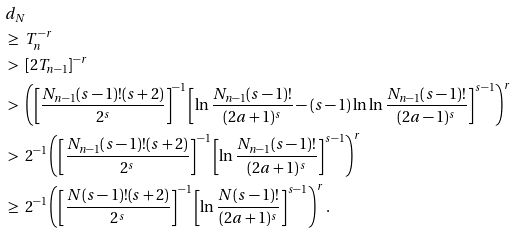<formula> <loc_0><loc_0><loc_500><loc_500>& d _ { N } \\ \ & \geq \ T _ { n } ^ { - r } \\ \ & > \ \left [ 2 T _ { n - 1 } \right ] ^ { - r } \\ \ & > \ \left ( \left [ \frac { N _ { n - 1 } ( s - 1 ) ! ( s + 2 ) } { 2 ^ { s } } \right ] ^ { - 1 } \left [ \ln \frac { N _ { n - 1 } ( s - 1 ) ! } { ( 2 a + 1 ) ^ { s } } - ( s - 1 ) \ln \ln \frac { N _ { n - 1 } ( s - 1 ) ! } { ( 2 a - 1 ) ^ { s } } \right ] ^ { s - 1 } \right ) ^ { r } \\ \ & > \ 2 ^ { - 1 } \left ( \left [ \frac { N _ { n - 1 } ( s - 1 ) ! ( s + 2 ) } { 2 ^ { s } } \right ] ^ { - 1 } \left [ \ln \frac { N _ { n - 1 } ( s - 1 ) ! } { ( 2 a + 1 ) ^ { s } } \right ] ^ { s - 1 } \right ) ^ { r } \\ \ & \geq \ 2 ^ { - 1 } \left ( \left [ \frac { N ( s - 1 ) ! ( s + 2 ) } { 2 ^ { s } } \right ] ^ { - 1 } \left [ \ln \frac { N ( s - 1 ) ! } { ( 2 a + 1 ) ^ { s } } \right ] ^ { s - 1 } \right ) ^ { r } .</formula> 